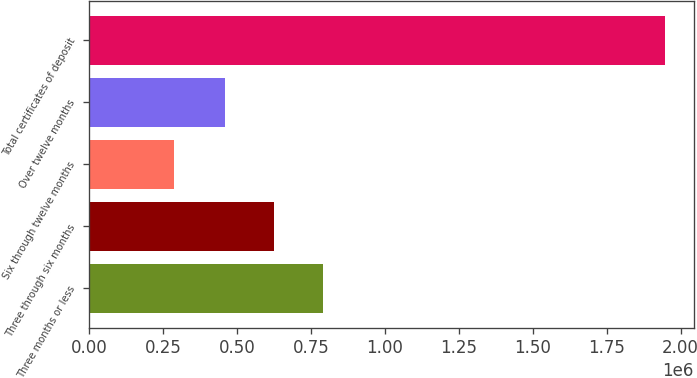Convert chart. <chart><loc_0><loc_0><loc_500><loc_500><bar_chart><fcel>Three months or less<fcel>Three through six months<fcel>Six through twelve months<fcel>Over twelve months<fcel>Total certificates of deposit<nl><fcel>790062<fcel>624177<fcel>287593<fcel>458292<fcel>1.94644e+06<nl></chart> 